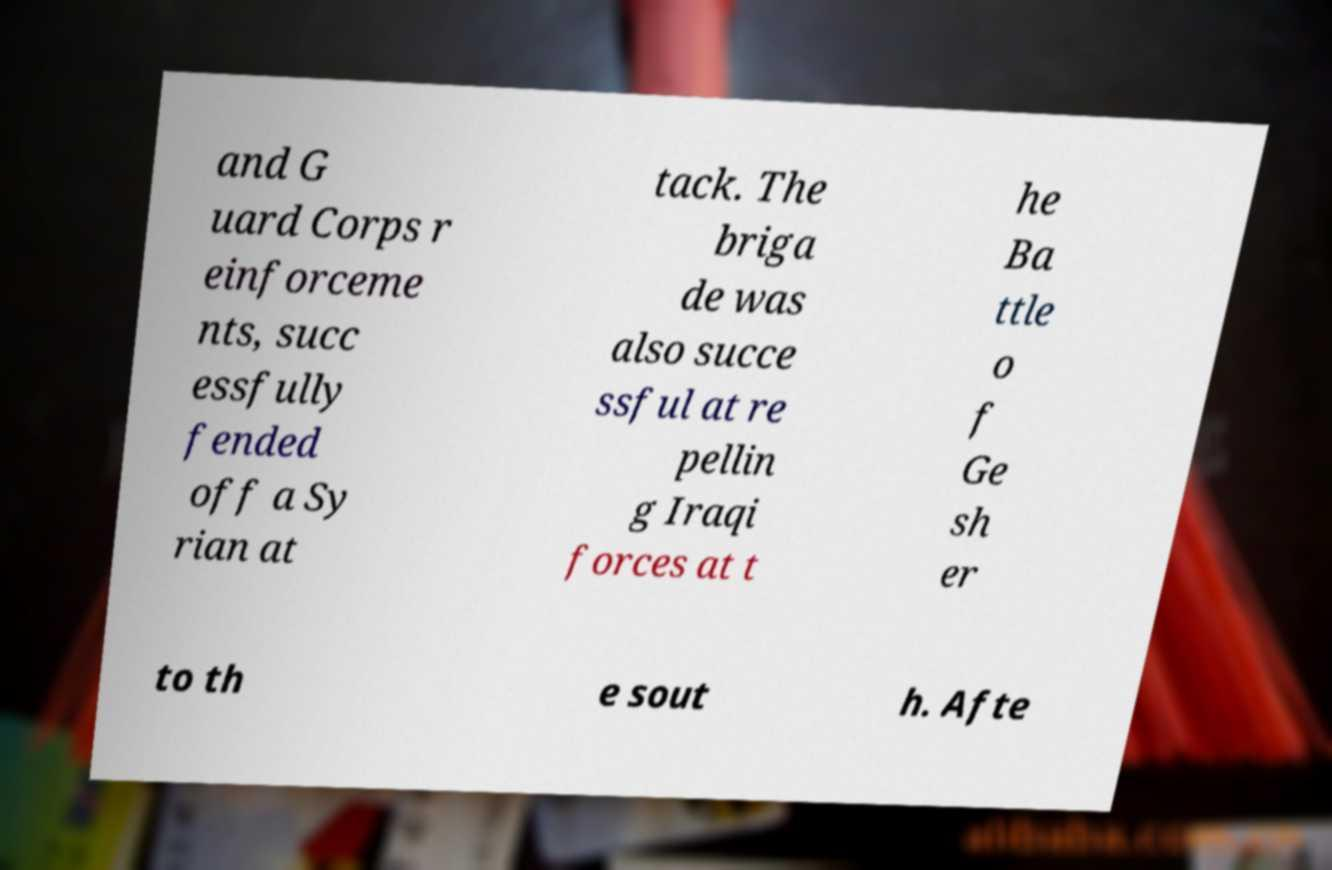Please identify and transcribe the text found in this image. and G uard Corps r einforceme nts, succ essfully fended off a Sy rian at tack. The briga de was also succe ssful at re pellin g Iraqi forces at t he Ba ttle o f Ge sh er to th e sout h. Afte 